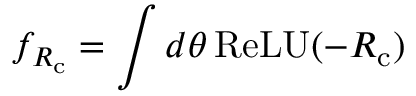<formula> <loc_0><loc_0><loc_500><loc_500>f _ { R _ { c } } = \int d \theta \, R e L U ( { - R _ { c } } )</formula> 